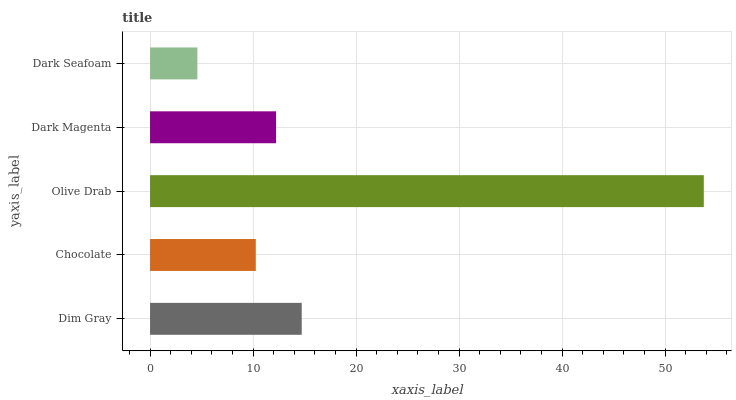Is Dark Seafoam the minimum?
Answer yes or no. Yes. Is Olive Drab the maximum?
Answer yes or no. Yes. Is Chocolate the minimum?
Answer yes or no. No. Is Chocolate the maximum?
Answer yes or no. No. Is Dim Gray greater than Chocolate?
Answer yes or no. Yes. Is Chocolate less than Dim Gray?
Answer yes or no. Yes. Is Chocolate greater than Dim Gray?
Answer yes or no. No. Is Dim Gray less than Chocolate?
Answer yes or no. No. Is Dark Magenta the high median?
Answer yes or no. Yes. Is Dark Magenta the low median?
Answer yes or no. Yes. Is Dim Gray the high median?
Answer yes or no. No. Is Dim Gray the low median?
Answer yes or no. No. 